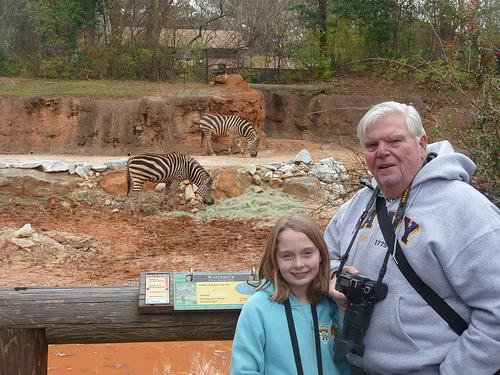Question: why is the girl smiling?
Choices:
A. She found a dollar.
B. She got an A on her test.
C. She got a new video game.
D. She's posing and also having a pleasant day.
Answer with the letter. Answer: D Question: how many zebras are in this scene?
Choices:
A. Three.
B. Four.
C. Five.
D. Two are visible.
Answer with the letter. Answer: D Question: what type of sweatshirt is the man wearing?
Choices:
A. A hooded one.
B. A green one.
C. A striped one.
D. A baggy one.
Answer with the letter. Answer: A Question: who is the oldest in the picture?
Choices:
A. The woman in the middle.
B. The grandmother.
C. The man on the right.
D. The tallest child.
Answer with the letter. Answer: C Question: what gives people information about the animals?
Choices:
A. The signs on the log.
B. Books.
C. Pamphlets.
D. Websites.
Answer with the letter. Answer: A Question: what hobby do the two people appear to share?
Choices:
A. Sky diving.
B. Skateboarding.
C. Photography.
D. Painting.
Answer with the letter. Answer: C Question: where does this scene take place?
Choices:
A. In Oakland.
B. In a museum.
C. At the zoo.
D. In Toronto.
Answer with the letter. Answer: C 